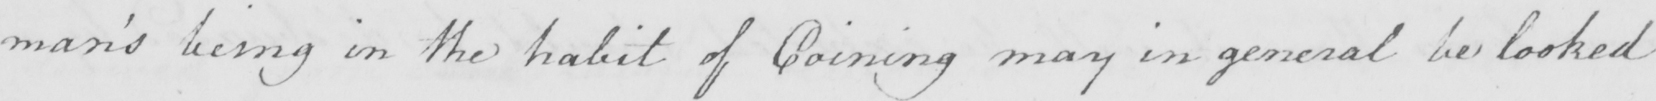Please transcribe the handwritten text in this image. man ' s being in the habit of Coining may in general be looked 